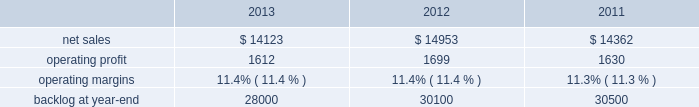Aeronautics our aeronautics business segment is engaged in the research , design , development , manufacture , integration , sustainment , support , and upgrade of advanced military aircraft , including combat and air mobility aircraft , unmanned air vehicles , and related technologies .
Aeronautics 2019 major programs include the f-35 lightning ii joint strike fighter , c-130 hercules , f-16 fighting falcon , f-22 raptor , and the c-5m super galaxy .
Aeronautics 2019 operating results included the following ( in millions ) : .
2013 compared to 2012 aeronautics 2019 net sales for 2013 decreased $ 830 million , or 6% ( 6 % ) , compared to 2012 .
The decrease was primarily attributable to lower net sales of approximately $ 530 million for the f-16 program due to fewer aircraft deliveries ( 13 aircraft delivered in 2013 compared to 37 delivered in 2012 ) partially offset by aircraft configuration mix ; about $ 385 million for the c-130 program due to fewer aircraft deliveries ( 25 aircraft delivered in 2013 compared to 34 in 2012 ) partially offset by increased sustainment activities ; approximately $ 255 million for the f-22 program , which includes about $ 205 million due to decreased production volume as final aircraft deliveries were completed during the second quarter of 2012 and $ 50 million from the favorable resolution of a contractual matter during the second quarter of 2012 ; and about $ 270 million for various other programs ( primarily sustainment activities ) due to decreased volume .
The decreases were partially offset by higher net sales of about $ 295 million for f-35 production contracts due to increased production volume and risk retirements ; approximately $ 245 million for the c-5 program due to increased aircraft deliveries ( six aircraft delivered in 2013 compared to four in 2012 ) and other modernization activities ; and about $ 70 million for the f-35 development contract due to increased volume .
Aeronautics 2019 operating profit for 2013 decreased $ 87 million , or 5% ( 5 % ) , compared to 2012 .
The decrease was primarily attributable to lower operating profit of about $ 85 million for the f-22 program , which includes approximately $ 50 million from the favorable resolution of a contractual matter in the second quarter of 2012 and about $ 35 million due to decreased risk retirements and production volume ; approximately $ 70 million for the c-130 program due to lower risk retirements and fewer deliveries partially offset by increased sustainment activities ; about $ 65 million for the c-5 program due to the inception-to-date effect of reducing the profit booking rate in the third quarter of 2013 and lower risk retirements ; approximately $ 35 million for the f-16 program due to fewer aircraft deliveries partially offset by increased sustainment activity and aircraft configuration mix .
The decreases were partially offset by higher operating profit of approximately $ 180 million for f-35 production contracts due to increased risk retirements and volume .
Operating profit was comparable for the f-35 development contract and included adjustments of approximately $ 85 million to reflect the inception-to-date impacts of the downward revisions to the profit booking rate in both 2013 and 2012 .
Adjustments not related to volume , including net profit booking rate adjustments and other matters , were approximately $ 75 million lower for 2013 compared to 2012 compared to 2011 aeronautics 2019 net sales for 2012 increased $ 591 million , or 4% ( 4 % ) , compared to 2011 .
The increase was attributable to higher net sales of approximately $ 745 million from f-35 production contracts principally due to increased production volume ; about $ 285 million from f-16 programs primarily due to higher aircraft deliveries ( 37 f-16 aircraft delivered in 2012 compared to 22 in 2011 ) partially offset by lower volume on sustainment activities due to the completion of modification programs for certain international customers ; and approximately $ 140 million from c-5 programs due to higher aircraft deliveries ( four c-5m aircraft delivered in 2012 compared to two in 2011 ) .
Partially offsetting the increases were lower net sales of approximately $ 365 million from decreased production volume and lower risk retirements on the f-22 program as final aircraft deliveries were completed in the second quarter of 2012 ; approximately $ 110 million from the f-35 development contract primarily due to the inception-to-date effect of reducing the profit booking rate in the second quarter of 2012 and to a lesser extent lower volume ; and about $ 95 million from a decrease in volume on other sustainment activities partially offset by various other aeronautics programs due to higher volume .
Net sales for c-130 programs were comparable to 2011 as a decline in sustainment activities largely was offset by increased aircraft deliveries. .
As part of the total decrease of aeronautics 2019 net sales for 2013 what was the percent of the potential factor based on the lower sales of? 
Computations: (530 / 830)
Answer: 0.63855. 